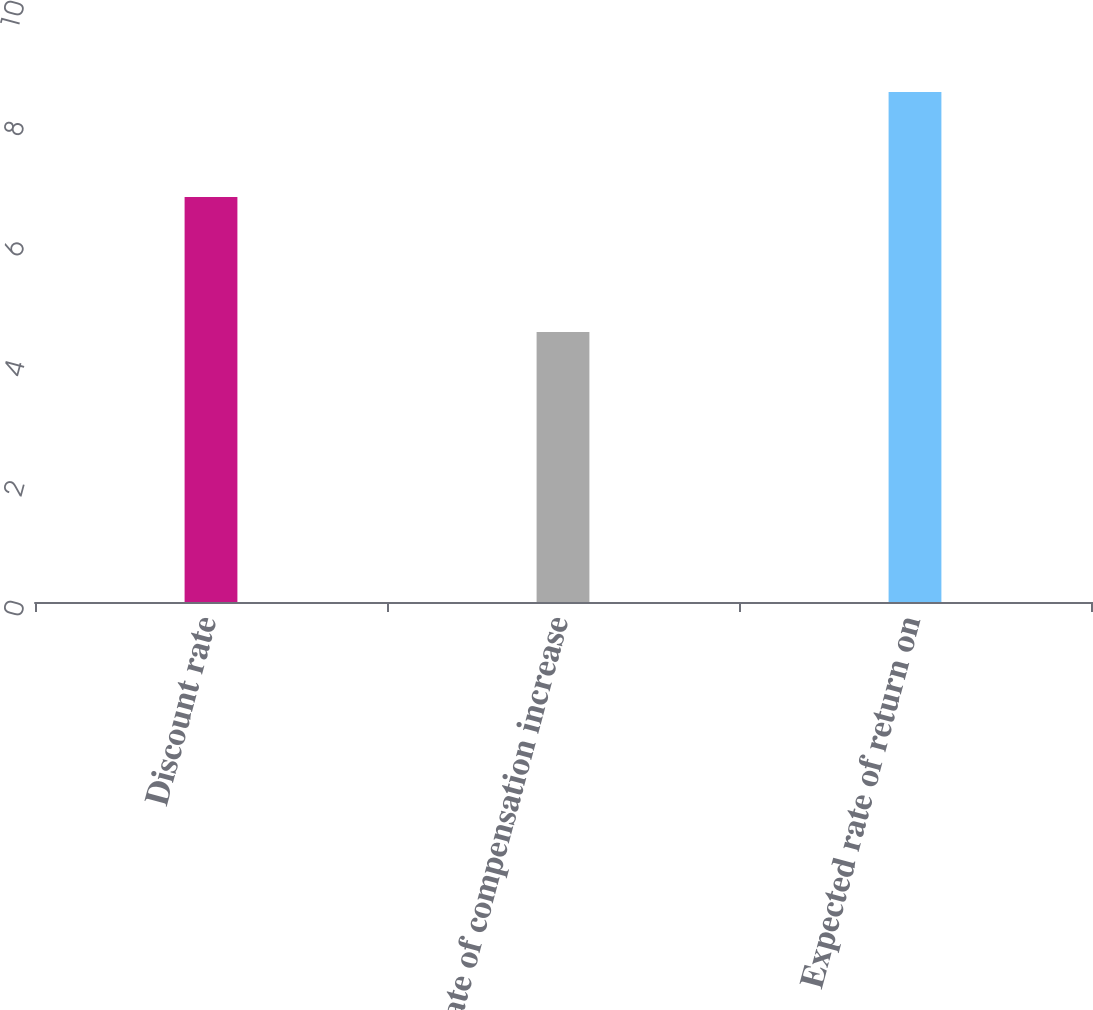Convert chart to OTSL. <chart><loc_0><loc_0><loc_500><loc_500><bar_chart><fcel>Discount rate<fcel>Rate of compensation increase<fcel>Expected rate of return on<nl><fcel>6.75<fcel>4.5<fcel>8.5<nl></chart> 